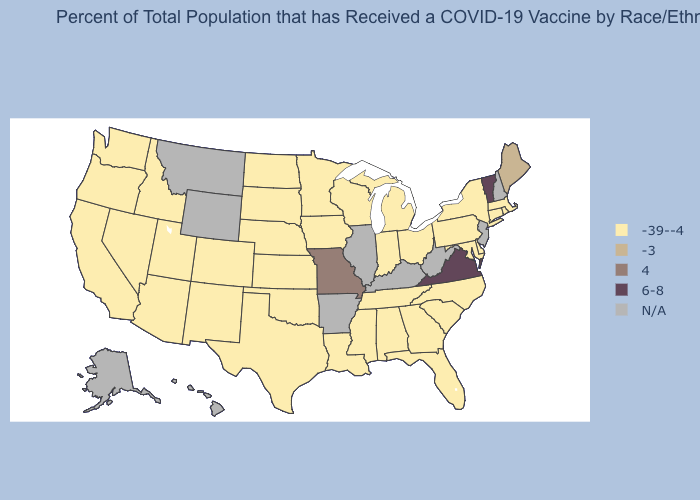Which states have the lowest value in the USA?
Write a very short answer. Alabama, Arizona, California, Colorado, Connecticut, Delaware, Florida, Georgia, Idaho, Indiana, Iowa, Kansas, Louisiana, Maryland, Massachusetts, Michigan, Minnesota, Mississippi, Nebraska, Nevada, New Mexico, New York, North Carolina, North Dakota, Ohio, Oklahoma, Oregon, Pennsylvania, Rhode Island, South Carolina, South Dakota, Tennessee, Texas, Utah, Washington, Wisconsin. What is the value of Louisiana?
Keep it brief. -39--4. Is the legend a continuous bar?
Concise answer only. No. Does Vermont have the highest value in the USA?
Concise answer only. Yes. Among the states that border Wisconsin , which have the lowest value?
Short answer required. Iowa, Michigan, Minnesota. Among the states that border Illinois , does Missouri have the lowest value?
Answer briefly. No. Does the map have missing data?
Answer briefly. Yes. Name the states that have a value in the range N/A?
Short answer required. Alaska, Arkansas, Hawaii, Illinois, Kentucky, Montana, New Hampshire, New Jersey, West Virginia, Wyoming. Which states have the lowest value in the MidWest?
Quick response, please. Indiana, Iowa, Kansas, Michigan, Minnesota, Nebraska, North Dakota, Ohio, South Dakota, Wisconsin. 